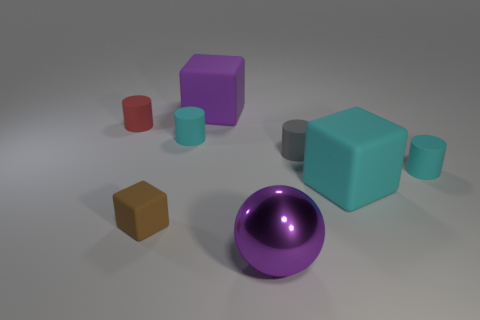Subtract all small cubes. How many cubes are left? 2 Add 1 balls. How many objects exist? 9 Subtract all spheres. How many objects are left? 7 Subtract 1 spheres. How many spheres are left? 0 Add 2 small gray cylinders. How many small gray cylinders exist? 3 Subtract all red cylinders. How many cylinders are left? 3 Subtract 1 purple spheres. How many objects are left? 7 Subtract all gray cubes. Subtract all green cylinders. How many cubes are left? 3 Subtract all gray spheres. How many gray blocks are left? 0 Subtract all purple things. Subtract all large purple balls. How many objects are left? 5 